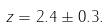<formula> <loc_0><loc_0><loc_500><loc_500>z = 2 . 4 \pm 0 . 3 .</formula> 